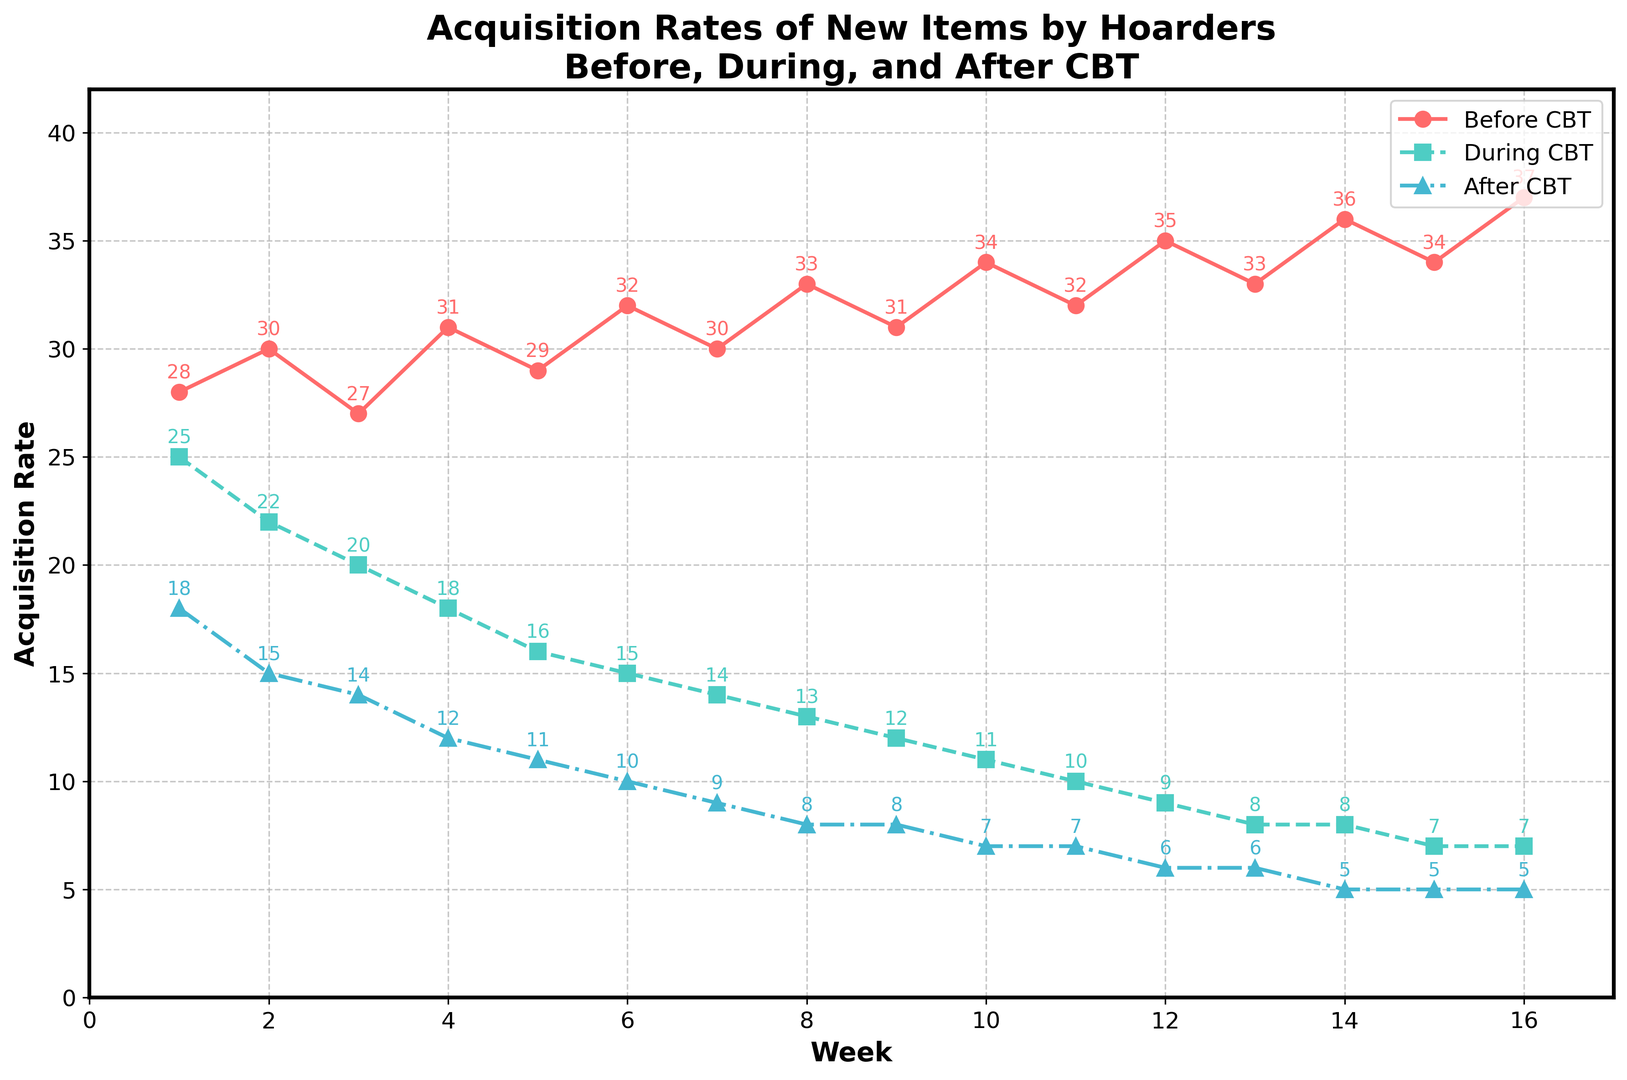What is the acquisition rate of new items by hoarders during CBT at week 5? Look for the data point corresponding to "During CBT" at week 5. The data shows an acquisition rate of 16.
Answer: 16 How does the acquisition rate after CBT compare to before CBT at week 10? Compare the data points for "After CBT" and "Before CBT" at week 10. After CBT is 7, and Before CBT is 34. Clearly, the rate is much lower after CBT.
Answer: After CBT is much lower What is the average acquisition rate of new items before CBT over the 16 weeks? Sum all the acquisition rates before CBT for each week and divide by 16. The sum is (28 + 30 + ... + 37) = 475. So, 475 / 16 = 29.69
Answer: 29.69 By how much did the acquisition rate decrease from week 1 to week 16 after CBT? Subtract the week 16 acquisition rate from the week 1 rate in the "After CBT" column. 18 (week 1) - 5 (week 16) = 13
Answer: 13 What week during CBT saw the largest decrease in acquisition rate compared to the previous week? Compare the acquisition rates week by week for "During CBT." The largest decrease is from week 1 (25) to week 2 (22), which is a decrease of 3.
Answer: Week 1 to Week 2 Which line in the chart generally shows the steepest decline over the 16 weeks? Visually compare the slopes of the three lines. Both "During CBT" and "After CBT" decline, but the "During CBT" line generally shows the steepest decline.
Answer: During CBT What is the total number of items acquired after CBT over the 16 weeks? Sum the acquisition rates for all the weeks in the "After CBT" column. The sum is (18 + 15 + ... + 5) = 136.
Answer: 136 If we average the acquisition rates during CBT from weeks 5 to 8, what number do we get? Sum the values during CBT from weeks 5 to 8: 16 + 15 + 14 + 13 = 58, then divide by 4. 58 / 4 = 14.5
Answer: 14.5 Which week had the lowest acquisition rate during CBT? Check the values under "During CBT" to find the minimum value, which occurs at week 13. The rate is 8.
Answer: Week 13 Is the acquisition rate at week 5 during CBT higher or lower than the acquisition rate at week 5 before CBT? Compare the values at week 5: 16 (During CBT) vs 29 (Before CBT). During CBT is lower.
Answer: Lower 